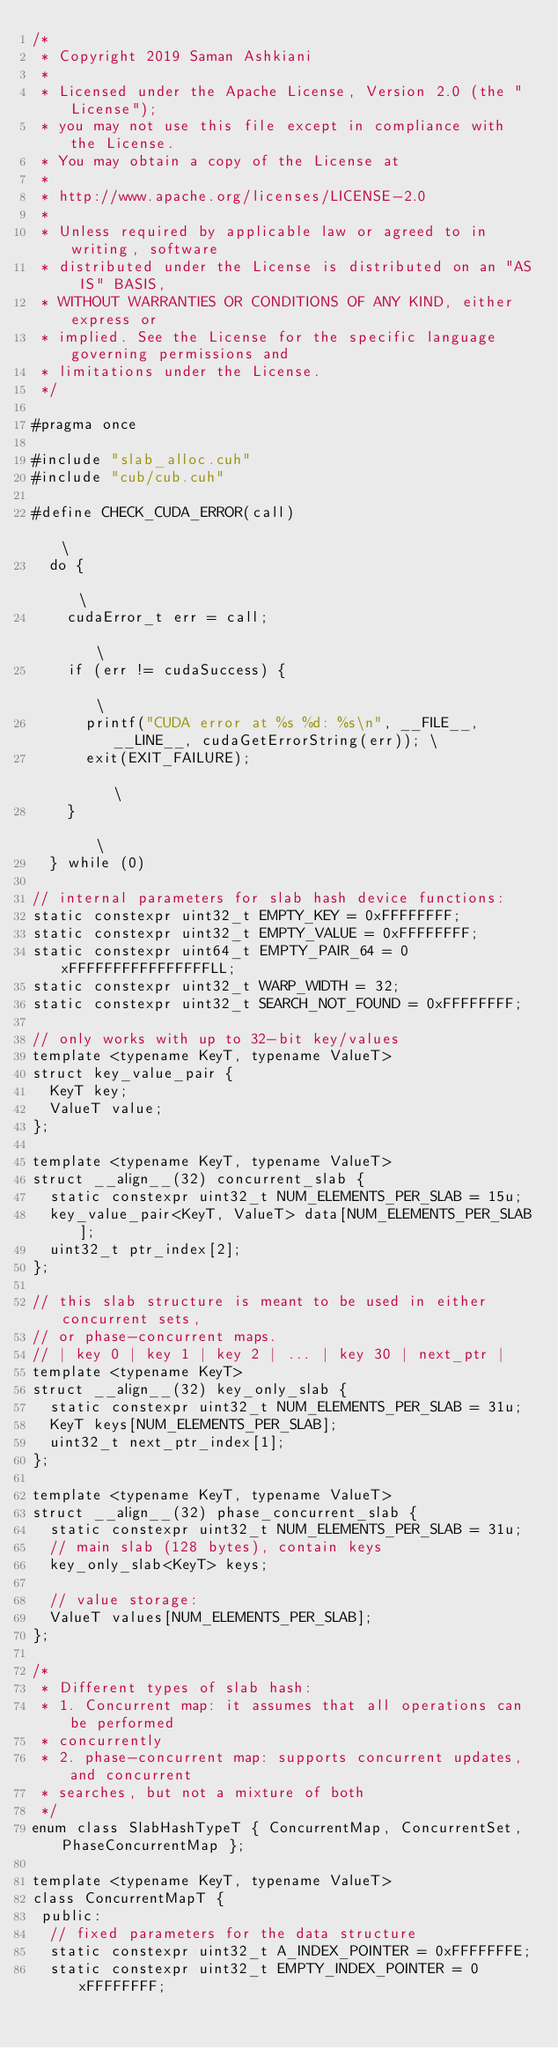<code> <loc_0><loc_0><loc_500><loc_500><_Cuda_>/*
 * Copyright 2019 Saman Ashkiani
 *
 * Licensed under the Apache License, Version 2.0 (the "License");
 * you may not use this file except in compliance with the License.
 * You may obtain a copy of the License at
 *
 * http://www.apache.org/licenses/LICENSE-2.0
 *
 * Unless required by applicable law or agreed to in writing, software
 * distributed under the License is distributed on an "AS IS" BASIS,
 * WITHOUT WARRANTIES OR CONDITIONS OF ANY KIND, either express or
 * implied. See the License for the specific language governing permissions and
 * limitations under the License.
 */

#pragma once

#include "slab_alloc.cuh"
#include "cub/cub.cuh"

#define CHECK_CUDA_ERROR(call)                                                          \
  do {                                                                                  \
    cudaError_t err = call;                                                             \
    if (err != cudaSuccess) {                                                           \
      printf("CUDA error at %s %d: %s\n", __FILE__, __LINE__, cudaGetErrorString(err)); \
      exit(EXIT_FAILURE);                                                               \
    }                                                                                   \
  } while (0)

// internal parameters for slab hash device functions:
static constexpr uint32_t EMPTY_KEY = 0xFFFFFFFF;
static constexpr uint32_t EMPTY_VALUE = 0xFFFFFFFF;
static constexpr uint64_t EMPTY_PAIR_64 = 0xFFFFFFFFFFFFFFFFLL;
static constexpr uint32_t WARP_WIDTH = 32;
static constexpr uint32_t SEARCH_NOT_FOUND = 0xFFFFFFFF;

// only works with up to 32-bit key/values
template <typename KeyT, typename ValueT>
struct key_value_pair {
  KeyT key;
  ValueT value;
};

template <typename KeyT, typename ValueT>
struct __align__(32) concurrent_slab {
  static constexpr uint32_t NUM_ELEMENTS_PER_SLAB = 15u;
  key_value_pair<KeyT, ValueT> data[NUM_ELEMENTS_PER_SLAB];
  uint32_t ptr_index[2];
};

// this slab structure is meant to be used in either concurrent sets,
// or phase-concurrent maps.
// | key 0 | key 1 | key 2 | ... | key 30 | next_ptr |
template <typename KeyT>
struct __align__(32) key_only_slab {
  static constexpr uint32_t NUM_ELEMENTS_PER_SLAB = 31u;
  KeyT keys[NUM_ELEMENTS_PER_SLAB];
  uint32_t next_ptr_index[1];
};

template <typename KeyT, typename ValueT>
struct __align__(32) phase_concurrent_slab {
  static constexpr uint32_t NUM_ELEMENTS_PER_SLAB = 31u;
  // main slab (128 bytes), contain keys
  key_only_slab<KeyT> keys;

  // value storage:
  ValueT values[NUM_ELEMENTS_PER_SLAB];
};

/*
 * Different types of slab hash:
 * 1. Concurrent map: it assumes that all operations can be performed
 * concurrently
 * 2. phase-concurrent map: supports concurrent updates, and concurrent
 * searches, but not a mixture of both
 */
enum class SlabHashTypeT { ConcurrentMap, ConcurrentSet, PhaseConcurrentMap };

template <typename KeyT, typename ValueT>
class ConcurrentMapT {
 public:
  // fixed parameters for the data structure
  static constexpr uint32_t A_INDEX_POINTER = 0xFFFFFFFE;
  static constexpr uint32_t EMPTY_INDEX_POINTER = 0xFFFFFFFF;</code> 